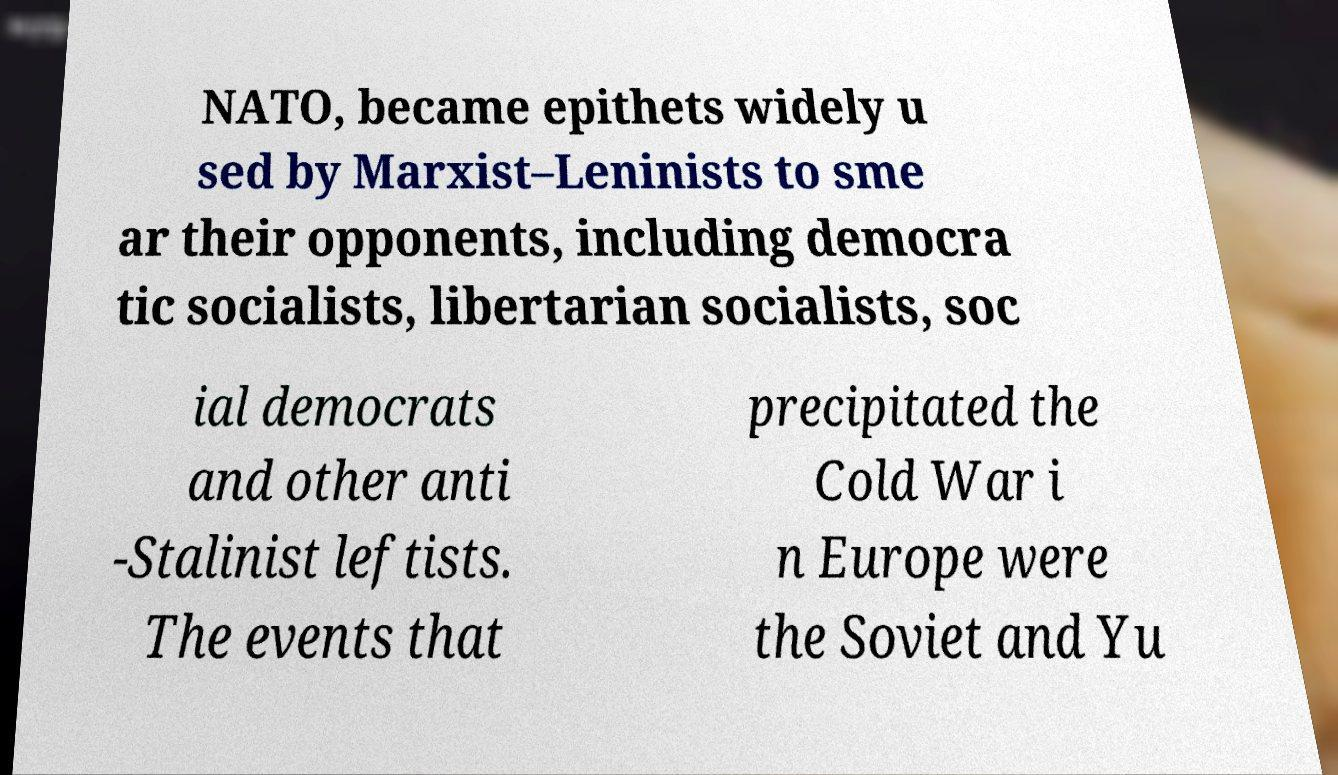Can you accurately transcribe the text from the provided image for me? NATO, became epithets widely u sed by Marxist–Leninists to sme ar their opponents, including democra tic socialists, libertarian socialists, soc ial democrats and other anti -Stalinist leftists. The events that precipitated the Cold War i n Europe were the Soviet and Yu 